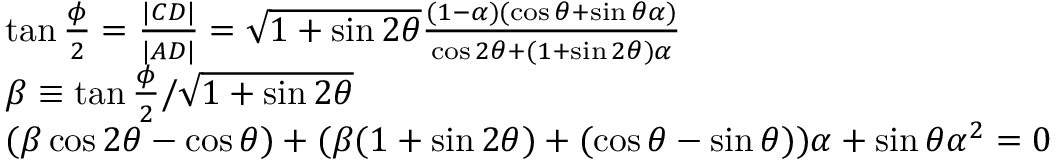<formula> <loc_0><loc_0><loc_500><loc_500>\begin{array} { r l } & { \tan \frac { \phi } { 2 } = \frac { | C D | } { | A D | } = \sqrt { 1 + \sin 2 \theta } \frac { ( 1 - \alpha ) ( \cos \theta + \sin \theta \alpha ) } { \cos 2 \theta + ( 1 + \sin 2 \theta ) \alpha } } \\ & { \beta \equiv \tan \frac { \phi } { 2 } / \sqrt { 1 + \sin 2 \theta } } \\ & { ( \beta \cos 2 \theta - \cos \theta ) + ( \beta ( 1 + \sin 2 \theta ) + ( \cos \theta - \sin \theta ) ) \alpha + \sin \theta \alpha ^ { 2 } = 0 } \end{array}</formula> 